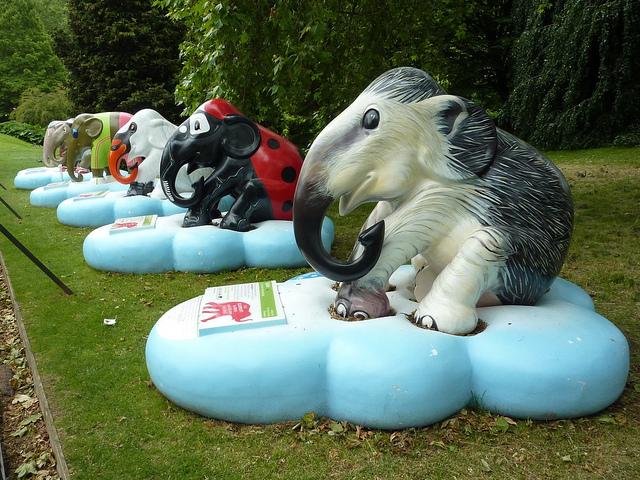How many sculptures are there?
Write a very short answer. 5. Do you like these elephants?
Be succinct. Yes. What are the animals on?
Be succinct. Clouds. 